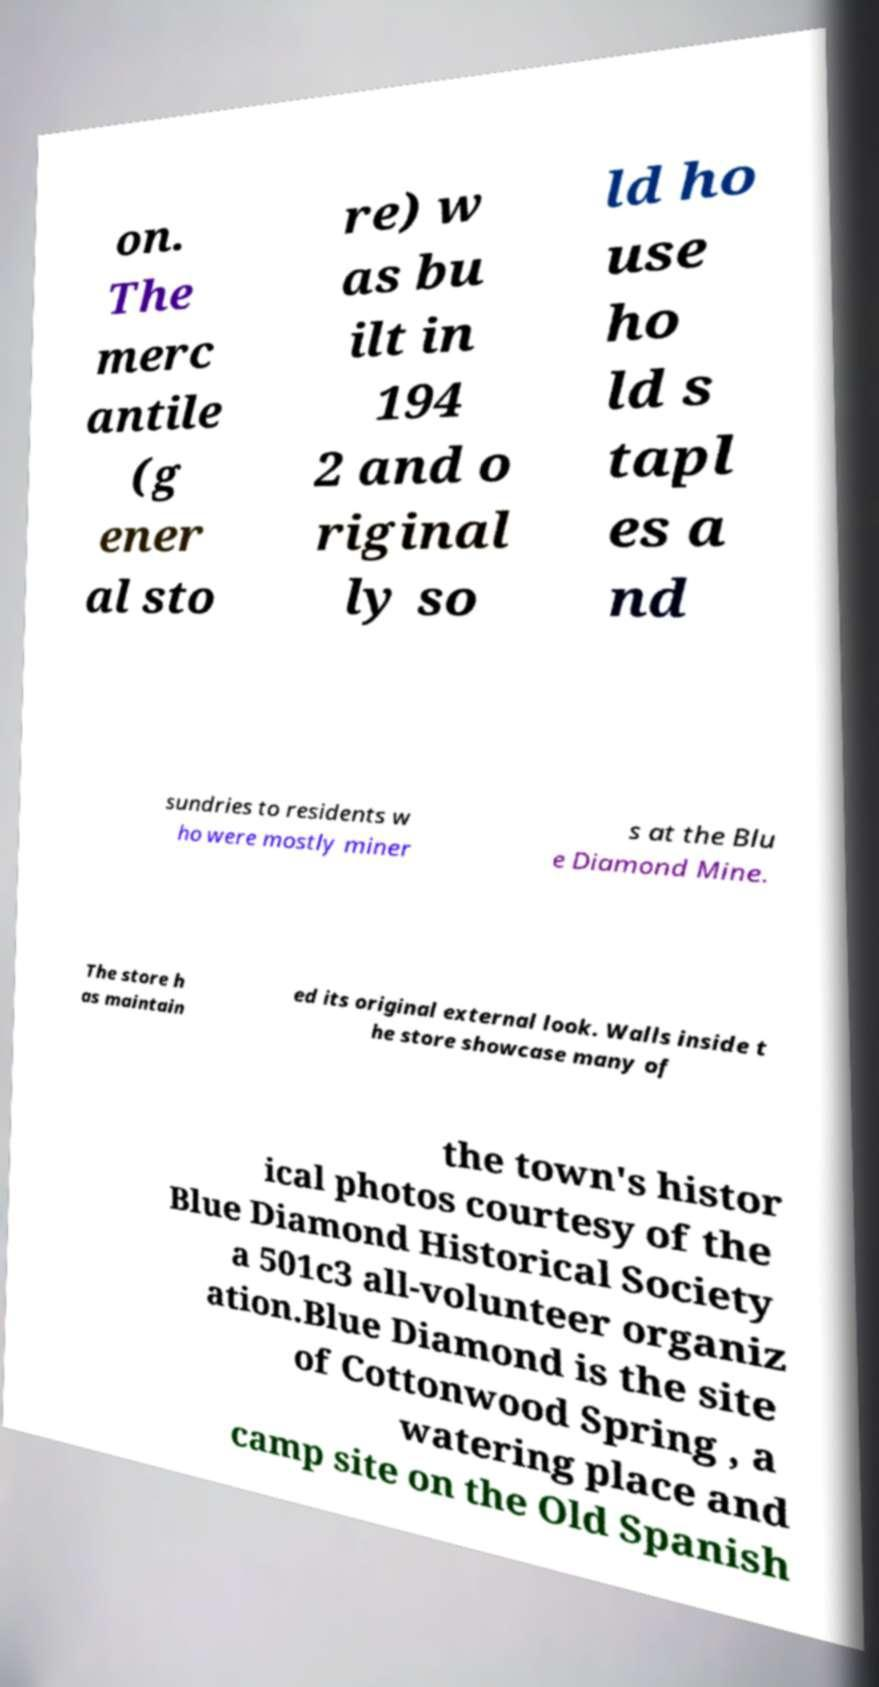Can you accurately transcribe the text from the provided image for me? on. The merc antile (g ener al sto re) w as bu ilt in 194 2 and o riginal ly so ld ho use ho ld s tapl es a nd sundries to residents w ho were mostly miner s at the Blu e Diamond Mine. The store h as maintain ed its original external look. Walls inside t he store showcase many of the town's histor ical photos courtesy of the Blue Diamond Historical Society a 501c3 all-volunteer organiz ation.Blue Diamond is the site of Cottonwood Spring , a watering place and camp site on the Old Spanish 